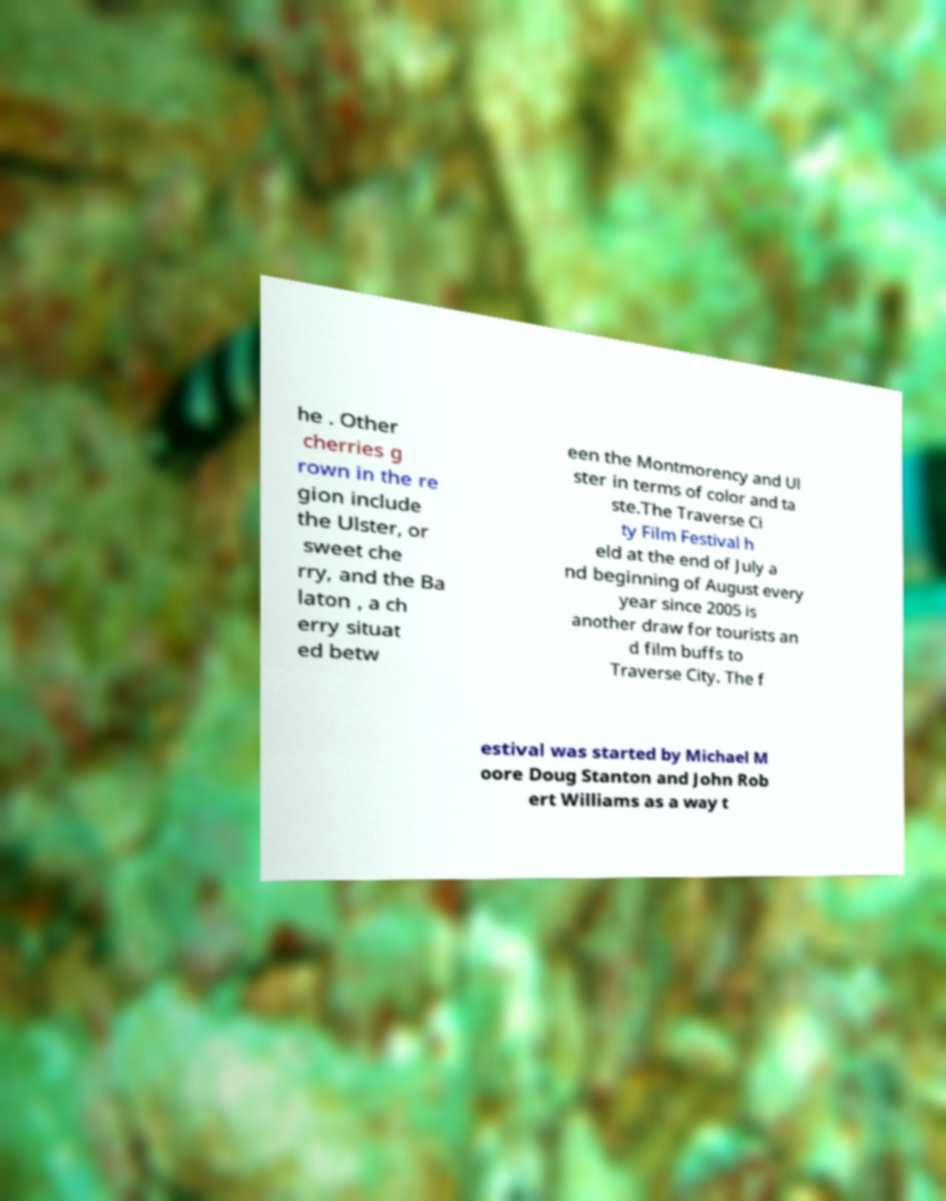I need the written content from this picture converted into text. Can you do that? he . Other cherries g rown in the re gion include the Ulster, or sweet che rry, and the Ba laton , a ch erry situat ed betw een the Montmorency and Ul ster in terms of color and ta ste.The Traverse Ci ty Film Festival h eld at the end of July a nd beginning of August every year since 2005 is another draw for tourists an d film buffs to Traverse City. The f estival was started by Michael M oore Doug Stanton and John Rob ert Williams as a way t 